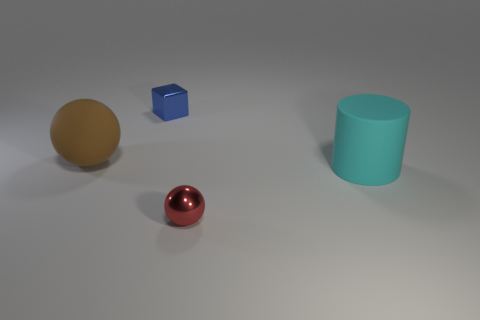Is the number of red rubber spheres greater than the number of things?
Offer a terse response. No. There is a red object that is the same size as the metal block; what material is it?
Your answer should be compact. Metal. There is a matte object to the left of the cyan thing; is its size the same as the cylinder?
Your response must be concise. Yes. How many balls are either large objects or red shiny things?
Keep it short and to the point. 2. What is the material of the large object behind the cyan object?
Give a very brief answer. Rubber. Is the number of big objects less than the number of big green matte cylinders?
Your answer should be very brief. No. What size is the object that is right of the brown matte ball and on the left side of the tiny red ball?
Provide a succinct answer. Small. There is a sphere on the left side of the red metal thing that is to the right of the small metal thing that is behind the red metal object; what is its size?
Make the answer very short. Large. What number of other things are there of the same color as the big matte cylinder?
Offer a terse response. 0. Do the matte thing left of the blue object and the metal cube have the same color?
Make the answer very short. No. 